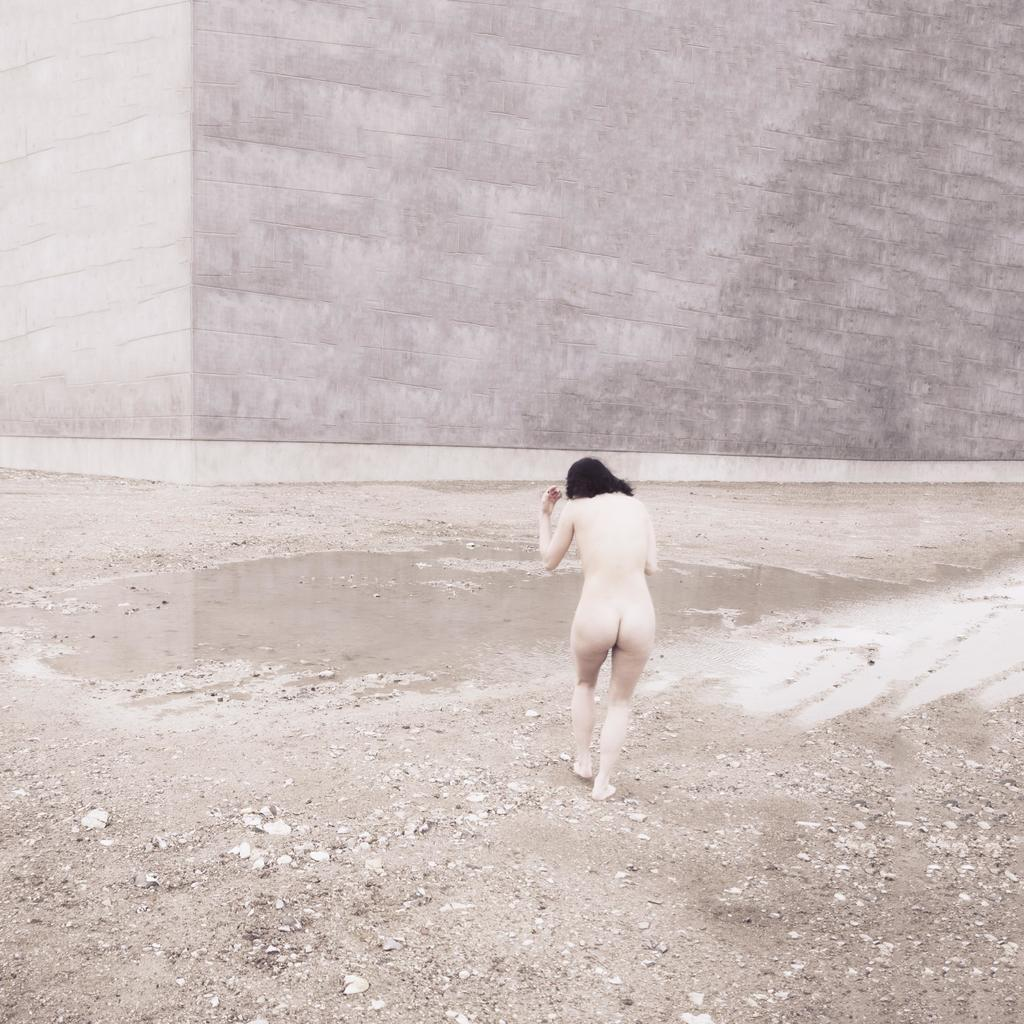Who is present in the image? There is a woman in the image. What is the woman doing in the image? The woman is walking. What type of terrain can be seen in the image? There is soil and rocks visible in the image. What is visible in the background of the image? There is a wall in the background of the image. What type of ball is being used for war in the image? There is no ball or war present in the image; it features a woman walking in a terrain with soil and rocks, and a wall in the background. 